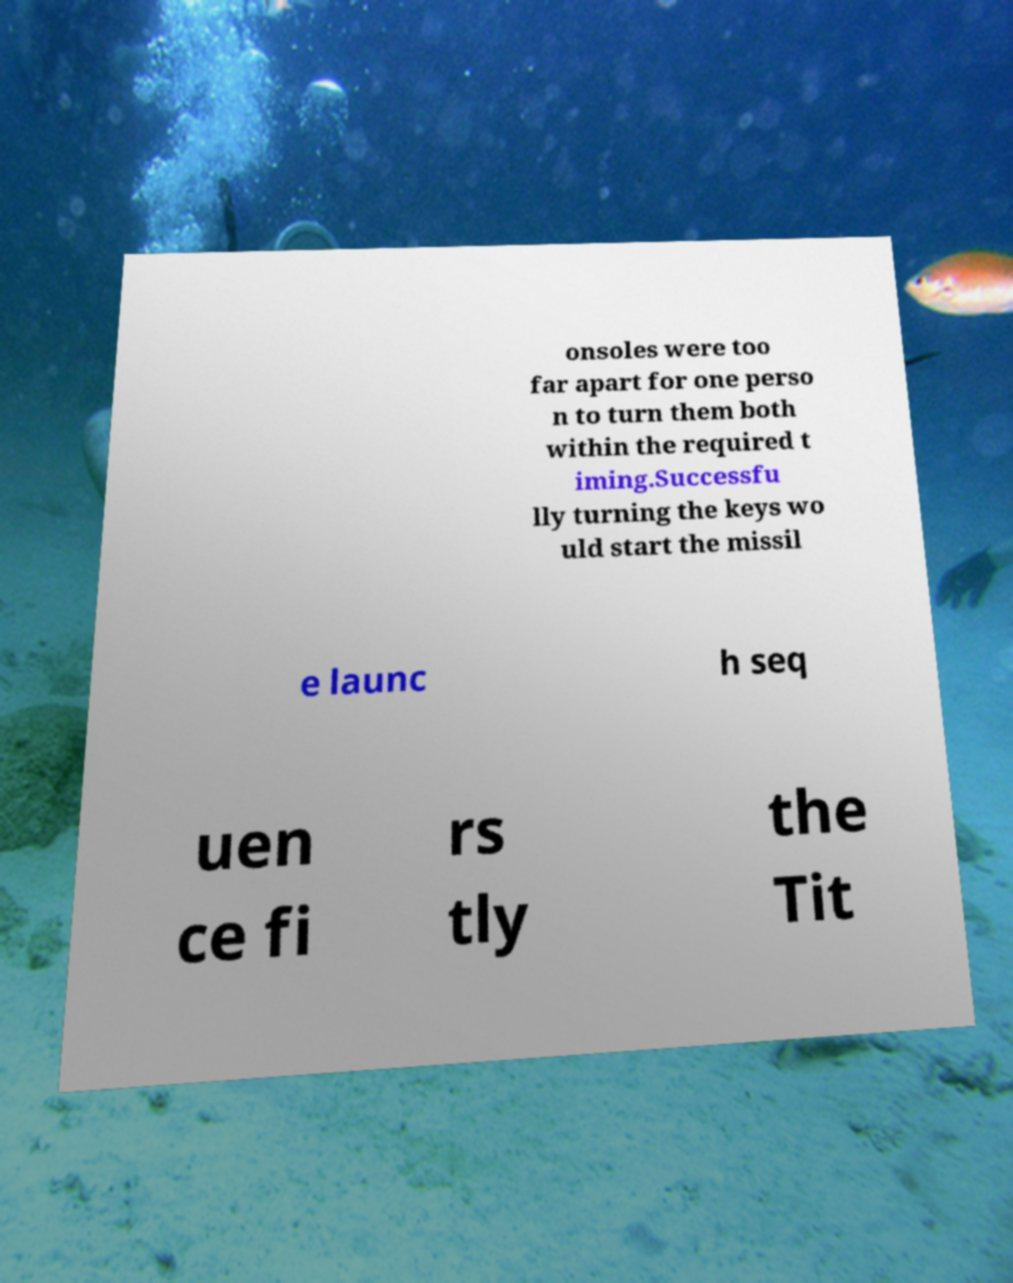What messages or text are displayed in this image? I need them in a readable, typed format. onsoles were too far apart for one perso n to turn them both within the required t iming.Successfu lly turning the keys wo uld start the missil e launc h seq uen ce fi rs tly the Tit 